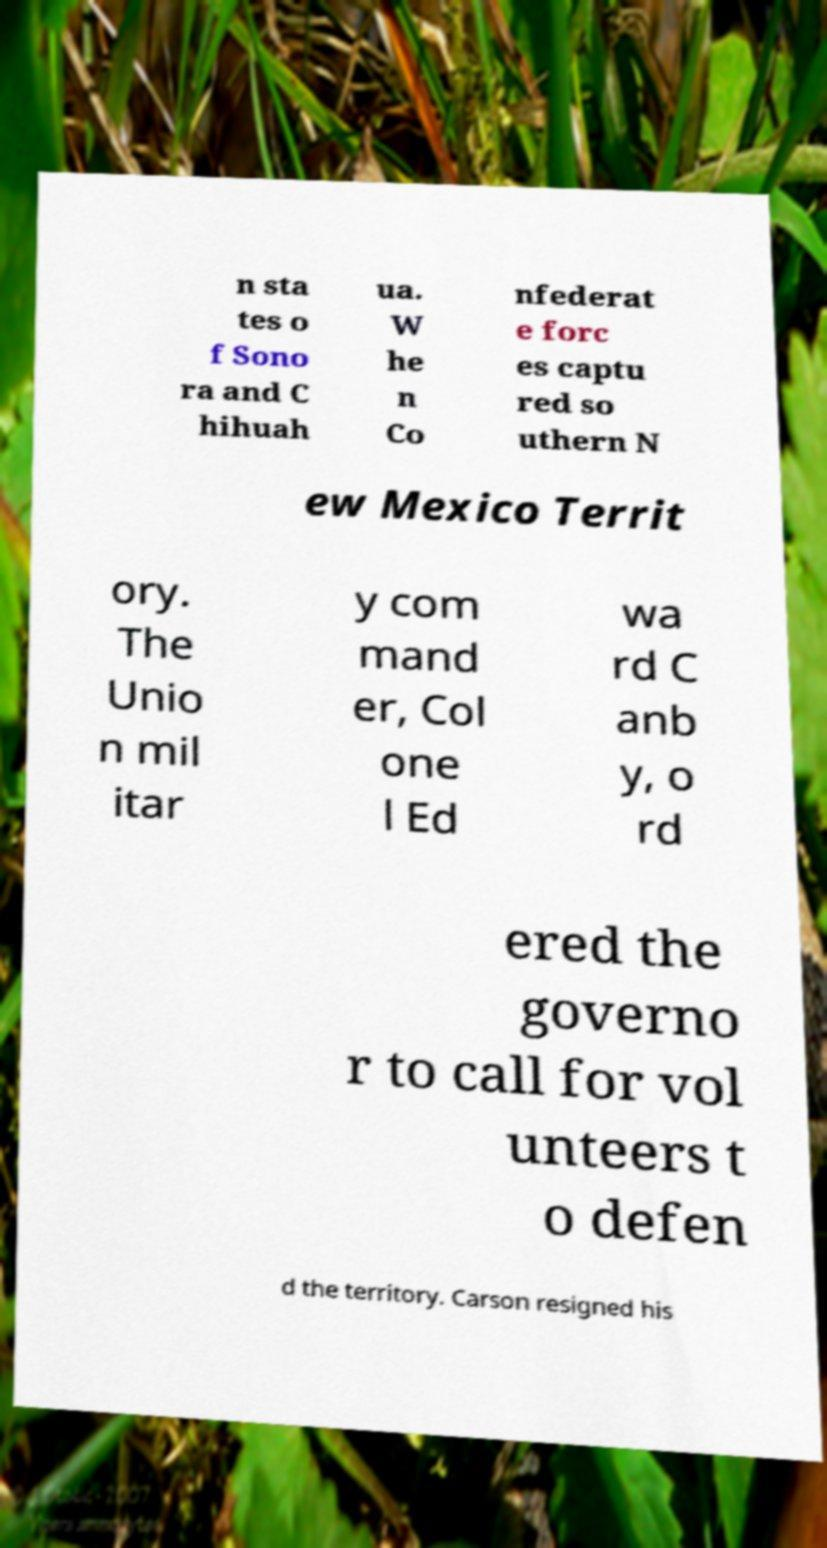Could you assist in decoding the text presented in this image and type it out clearly? n sta tes o f Sono ra and C hihuah ua. W he n Co nfederat e forc es captu red so uthern N ew Mexico Territ ory. The Unio n mil itar y com mand er, Col one l Ed wa rd C anb y, o rd ered the governo r to call for vol unteers t o defen d the territory. Carson resigned his 